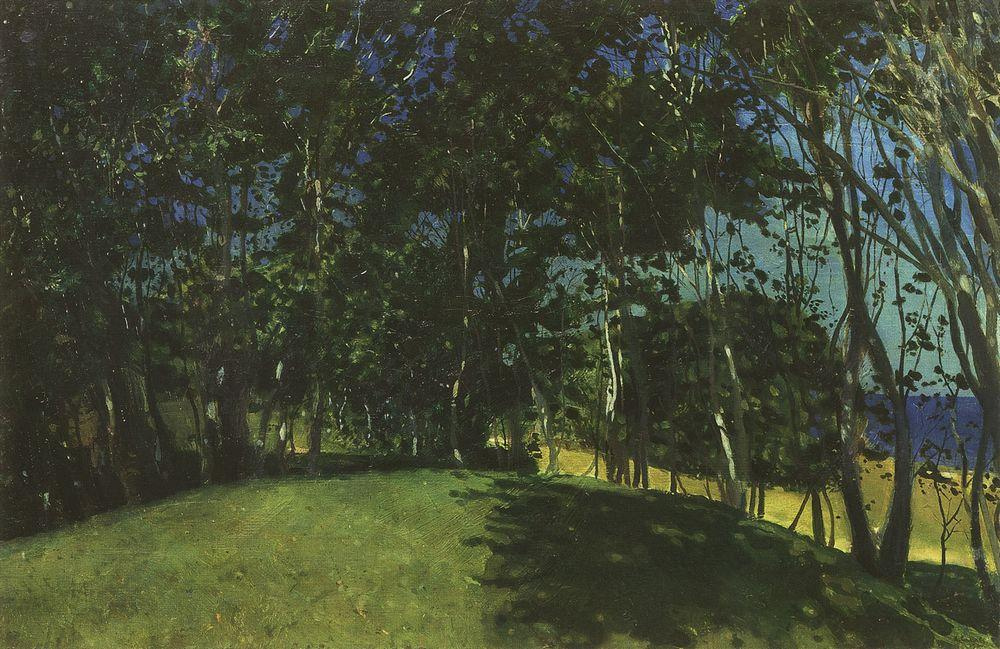What's happening in the scene? This image features an oil painting that beautifully depicts a tranquil forest scene using an impressionist technique. Each stroke and color choice is intentional, creating a dynamic interplay of light and shadow among the foliage, suggesting a serene, almost mystical exploration of nature. The foreground shows a well-trodden path, inviting the viewer to imagine a leisurely walk through this peaceful grove, while the use of darker greens and patches of light suggests the time of day might be late afternoon. The overall effect is calming and invites contemplation about the natural world. 